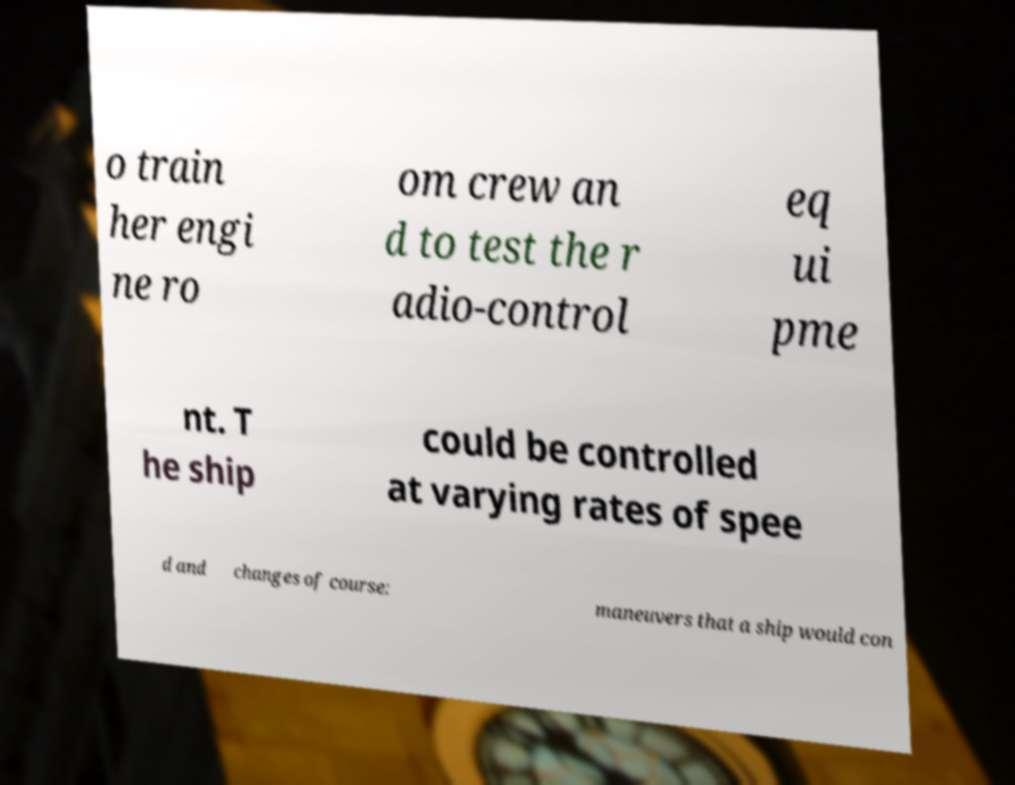I need the written content from this picture converted into text. Can you do that? o train her engi ne ro om crew an d to test the r adio-control eq ui pme nt. T he ship could be controlled at varying rates of spee d and changes of course: maneuvers that a ship would con 